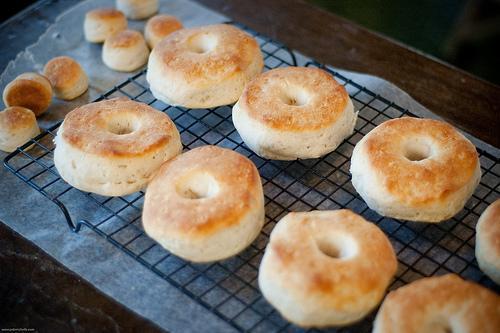How many things are not on the metal tray?
Give a very brief answer. 7. 